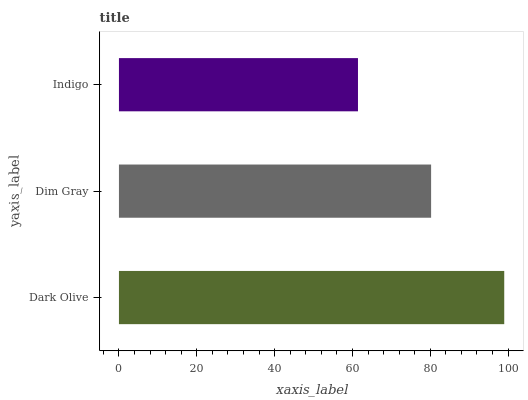Is Indigo the minimum?
Answer yes or no. Yes. Is Dark Olive the maximum?
Answer yes or no. Yes. Is Dim Gray the minimum?
Answer yes or no. No. Is Dim Gray the maximum?
Answer yes or no. No. Is Dark Olive greater than Dim Gray?
Answer yes or no. Yes. Is Dim Gray less than Dark Olive?
Answer yes or no. Yes. Is Dim Gray greater than Dark Olive?
Answer yes or no. No. Is Dark Olive less than Dim Gray?
Answer yes or no. No. Is Dim Gray the high median?
Answer yes or no. Yes. Is Dim Gray the low median?
Answer yes or no. Yes. Is Dark Olive the high median?
Answer yes or no. No. Is Dark Olive the low median?
Answer yes or no. No. 